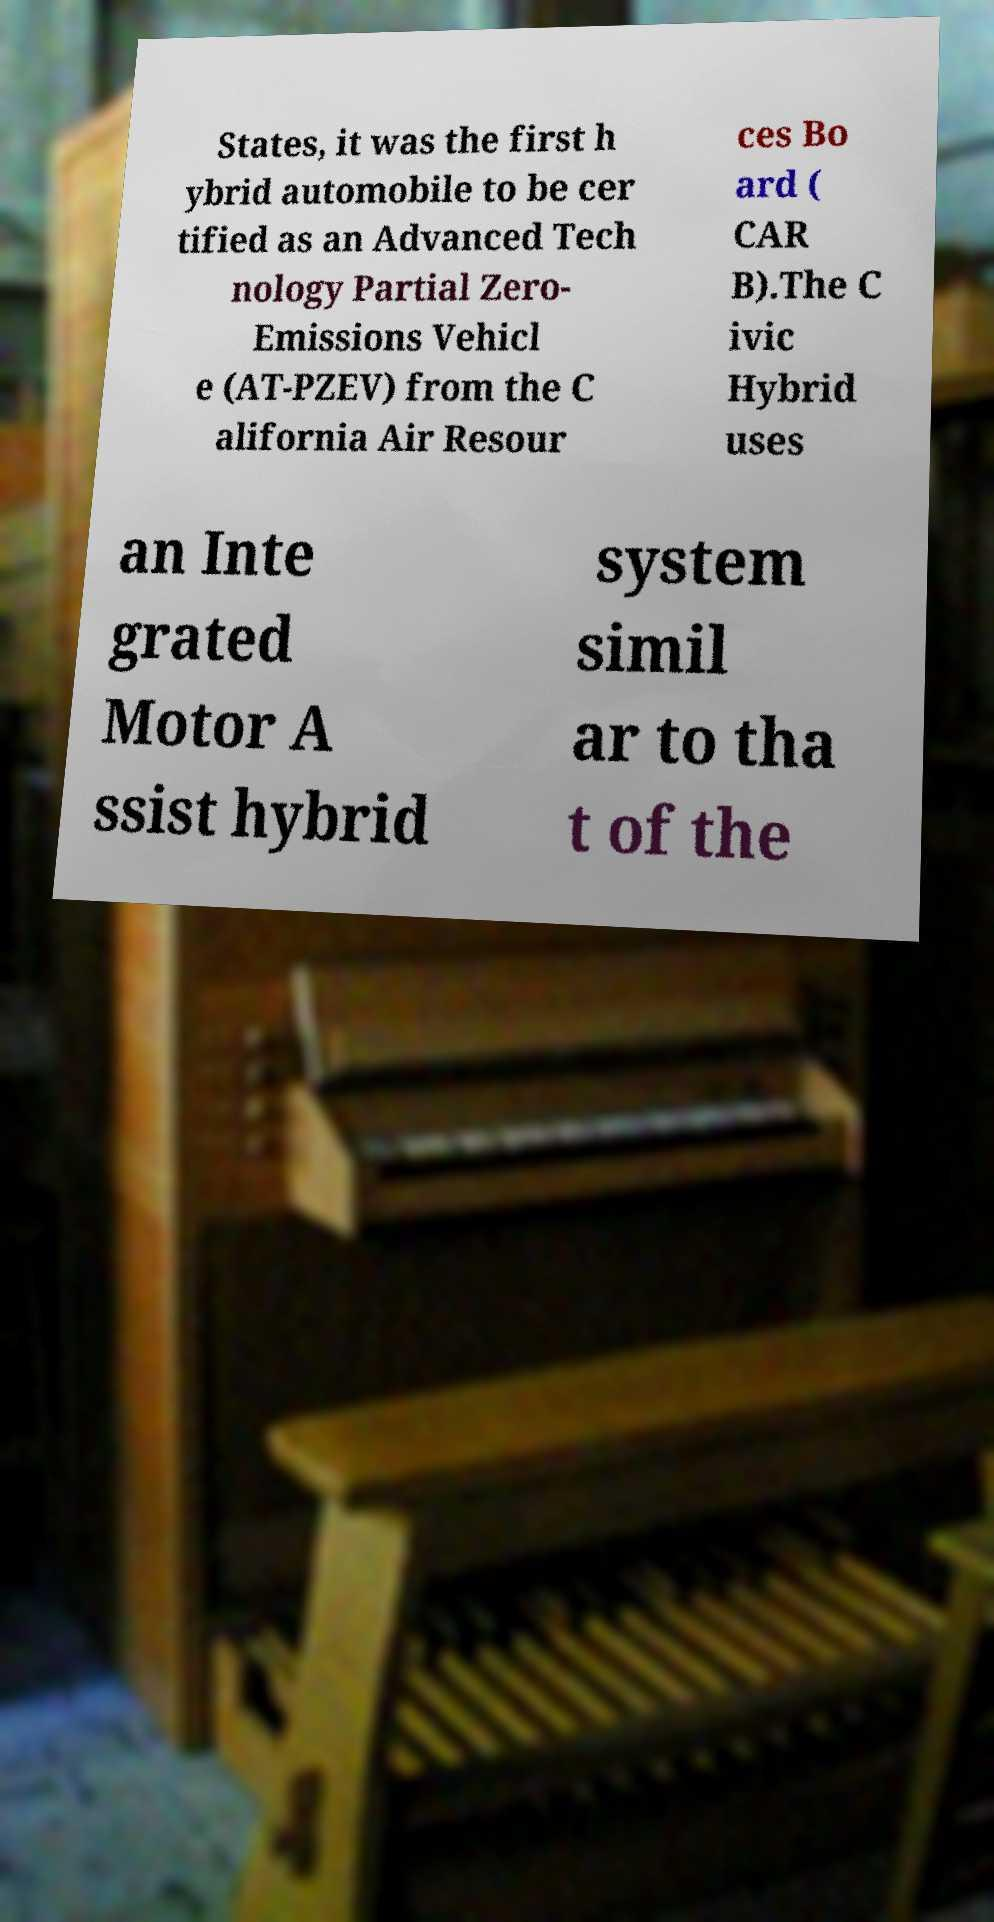Could you extract and type out the text from this image? States, it was the first h ybrid automobile to be cer tified as an Advanced Tech nology Partial Zero- Emissions Vehicl e (AT-PZEV) from the C alifornia Air Resour ces Bo ard ( CAR B).The C ivic Hybrid uses an Inte grated Motor A ssist hybrid system simil ar to tha t of the 